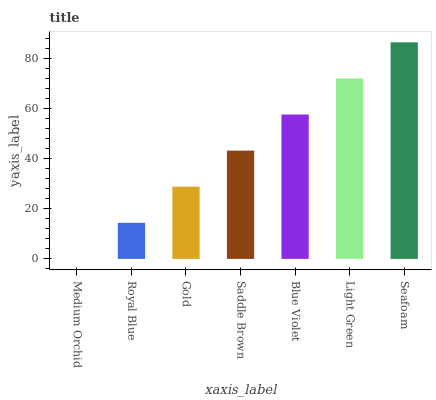Is Medium Orchid the minimum?
Answer yes or no. Yes. Is Seafoam the maximum?
Answer yes or no. Yes. Is Royal Blue the minimum?
Answer yes or no. No. Is Royal Blue the maximum?
Answer yes or no. No. Is Royal Blue greater than Medium Orchid?
Answer yes or no. Yes. Is Medium Orchid less than Royal Blue?
Answer yes or no. Yes. Is Medium Orchid greater than Royal Blue?
Answer yes or no. No. Is Royal Blue less than Medium Orchid?
Answer yes or no. No. Is Saddle Brown the high median?
Answer yes or no. Yes. Is Saddle Brown the low median?
Answer yes or no. Yes. Is Light Green the high median?
Answer yes or no. No. Is Medium Orchid the low median?
Answer yes or no. No. 